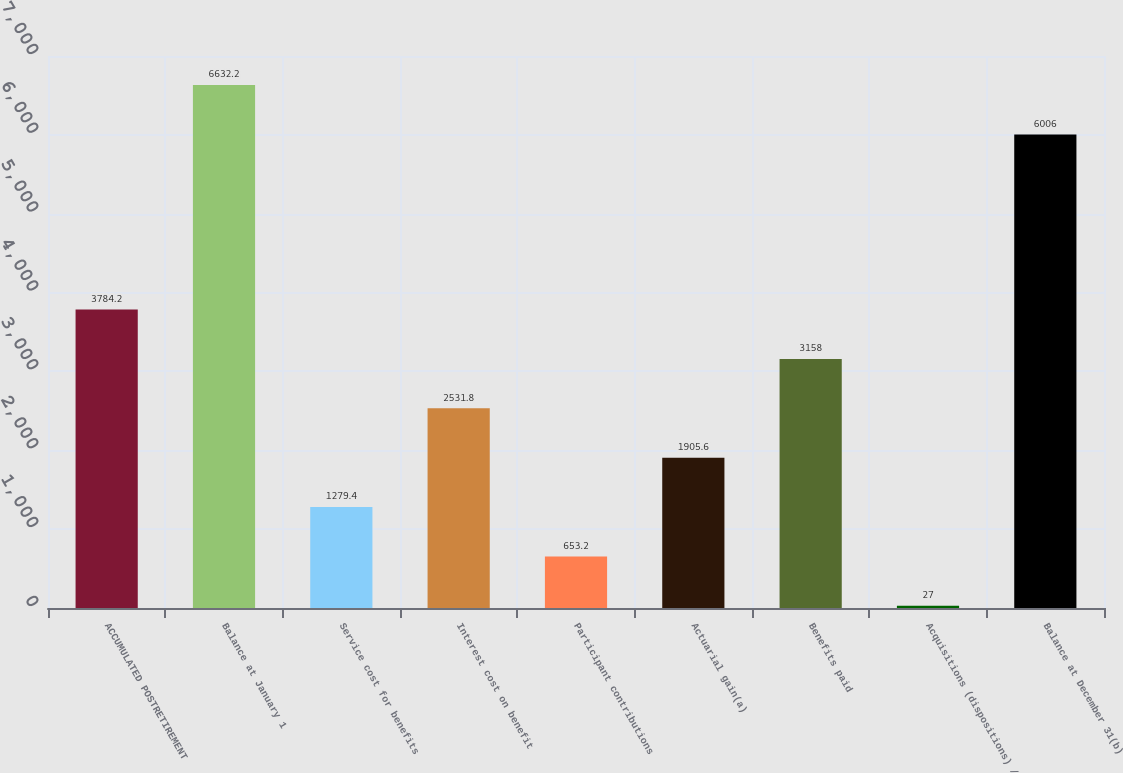Convert chart to OTSL. <chart><loc_0><loc_0><loc_500><loc_500><bar_chart><fcel>ACCUMULATED POSTRETIREMENT<fcel>Balance at January 1<fcel>Service cost for benefits<fcel>Interest cost on benefit<fcel>Participant contributions<fcel>Actuarial gain(a)<fcel>Benefits paid<fcel>Acquisitions (dispositions) /<fcel>Balance at December 31(b)<nl><fcel>3784.2<fcel>6632.2<fcel>1279.4<fcel>2531.8<fcel>653.2<fcel>1905.6<fcel>3158<fcel>27<fcel>6006<nl></chart> 